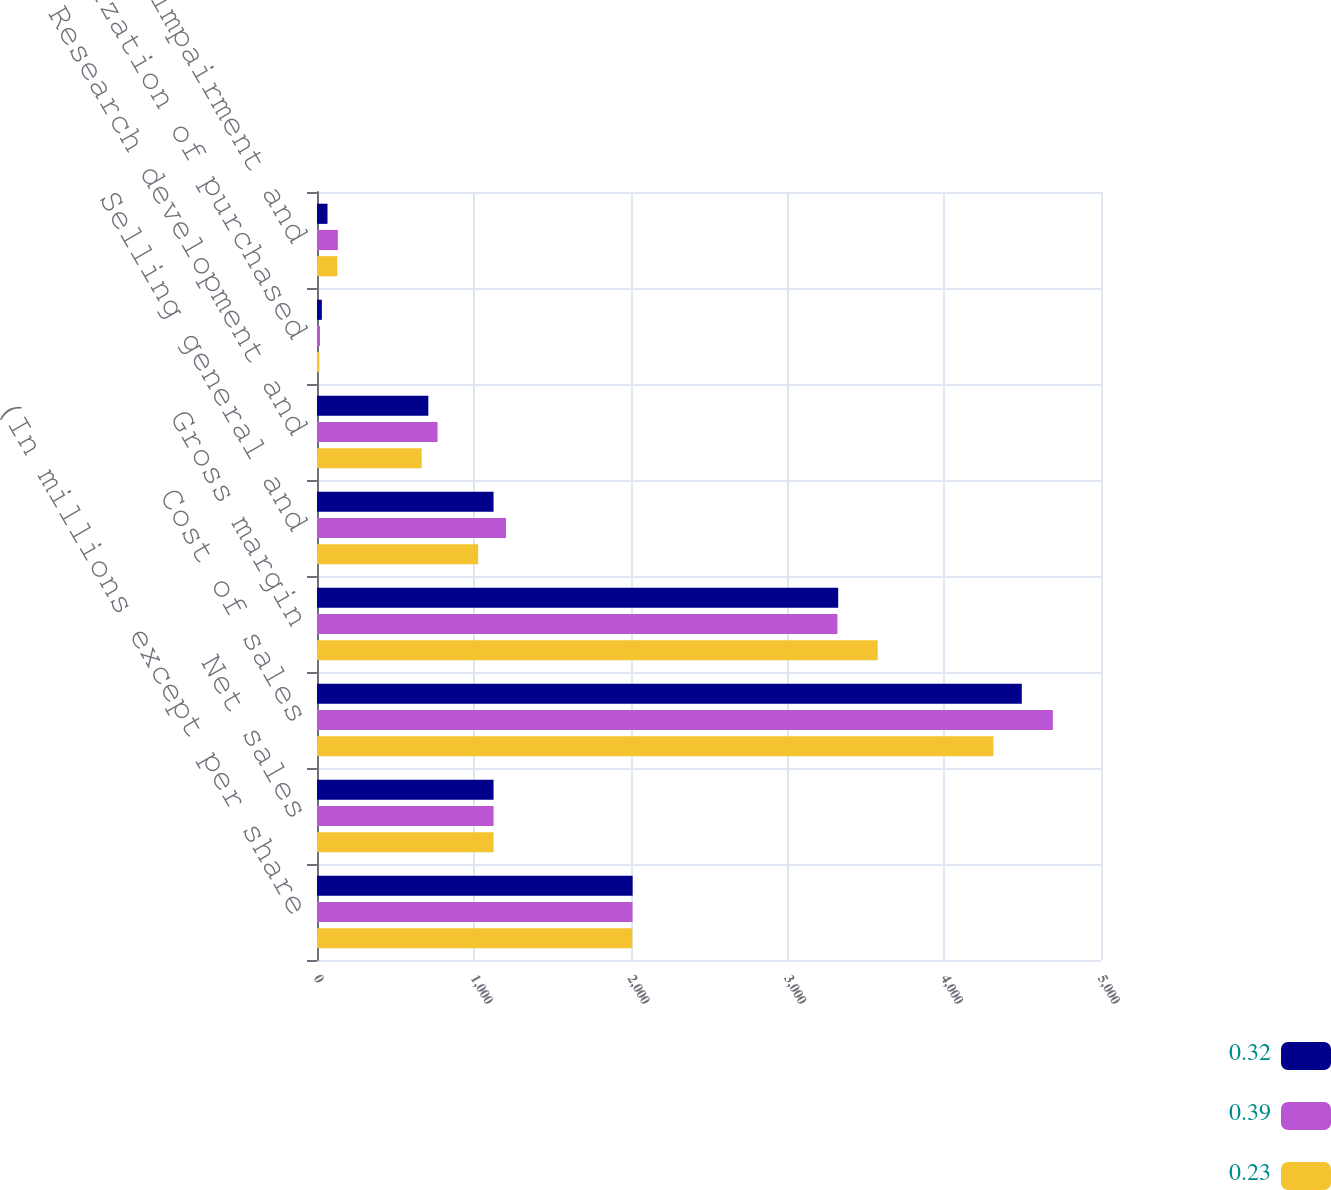Convert chart. <chart><loc_0><loc_0><loc_500><loc_500><stacked_bar_chart><ecel><fcel>(In millions except per share<fcel>Net sales<fcel>Cost of sales<fcel>Gross margin<fcel>Selling general and<fcel>Research development and<fcel>Amortization of purchased<fcel>Restructuring impairment and<nl><fcel>0.32<fcel>2013<fcel>1126<fcel>4495<fcel>3324<fcel>1126<fcel>710<fcel>31<fcel>67<nl><fcel>0.39<fcel>2012<fcel>1126<fcel>4693<fcel>3319<fcel>1205<fcel>769<fcel>19<fcel>133<nl><fcel>0.23<fcel>2011<fcel>1126<fcel>4314<fcel>3576<fcel>1028<fcel>668<fcel>15<fcel>129<nl></chart> 